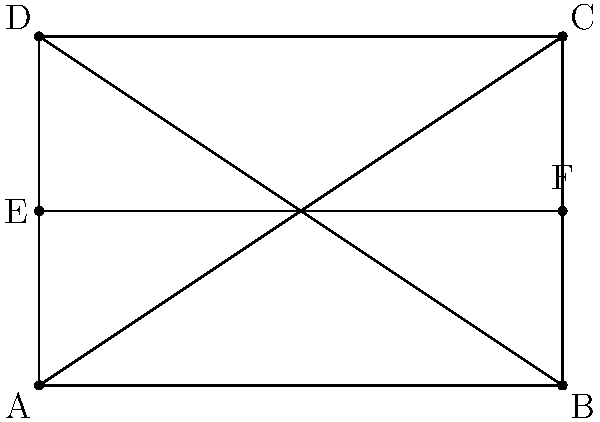On your rectangular tactics board, you've drawn two diagonal lines from corner to corner and a horizontal line through the middle. If the board has a width of 6 units and a height of 4 units, what is the angle (in degrees) between the two diagonal lines? Let's approach this step-by-step:

1) First, we need to find the angles that each diagonal makes with the horizontal:

   For triangle ABC:
   $\tan \theta = \frac{4}{6} = \frac{2}{3}$
   $\theta = \arctan(\frac{2}{3})$

2) The angle between the diagonals will be twice this angle:

   Angle between diagonals $= 2 \arctan(\frac{2}{3})$

3) Now, let's calculate this:

   $2 \arctan(\frac{2}{3}) \approx 2 * 33.69° = 67.38°$

4) We can verify this using the dot product formula:
   
   $\cos \theta = \frac{\vec{AC} \cdot \vec{BD}}{|\vec{AC}||\vec{BD}|}$

   where $\vec{AC} = (6,4)$ and $\vec{BD} = (6,-4)$

   $\cos \theta = \frac{6*6 + 4*(-4)}{\sqrt{6^2+4^2}\sqrt{6^2+(-4)^2}} = \frac{20}{52} \approx 0.3846$

   $\theta = \arccos(0.3846) \approx 67.38°$

This confirms our earlier calculation.
Answer: $67.38°$ 